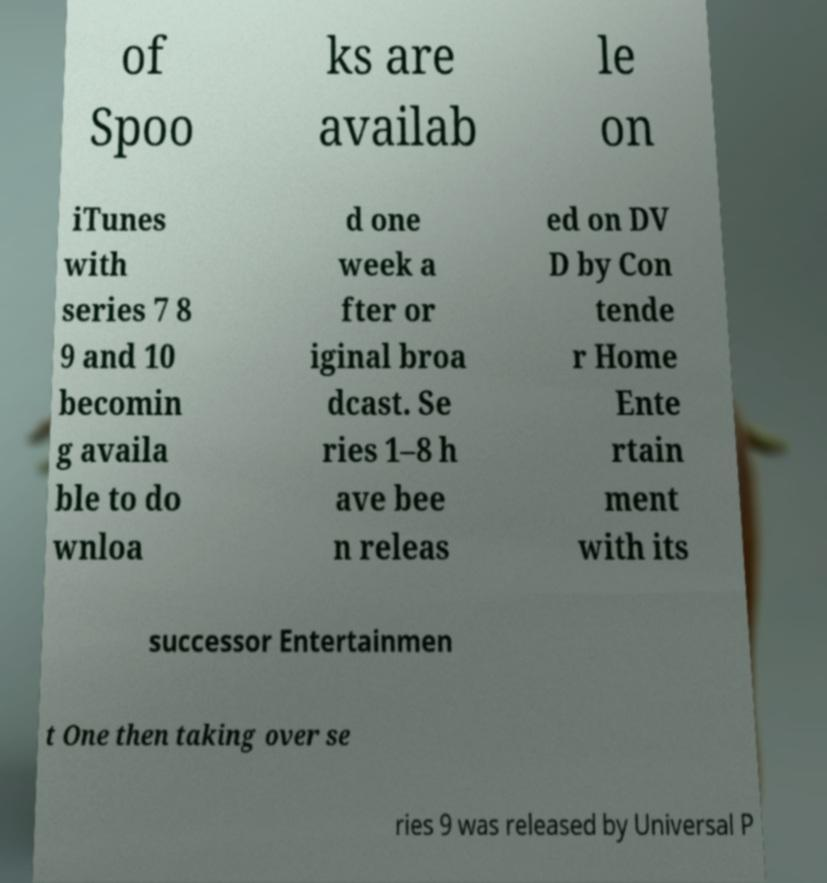Could you extract and type out the text from this image? of Spoo ks are availab le on iTunes with series 7 8 9 and 10 becomin g availa ble to do wnloa d one week a fter or iginal broa dcast. Se ries 1–8 h ave bee n releas ed on DV D by Con tende r Home Ente rtain ment with its successor Entertainmen t One then taking over se ries 9 was released by Universal P 